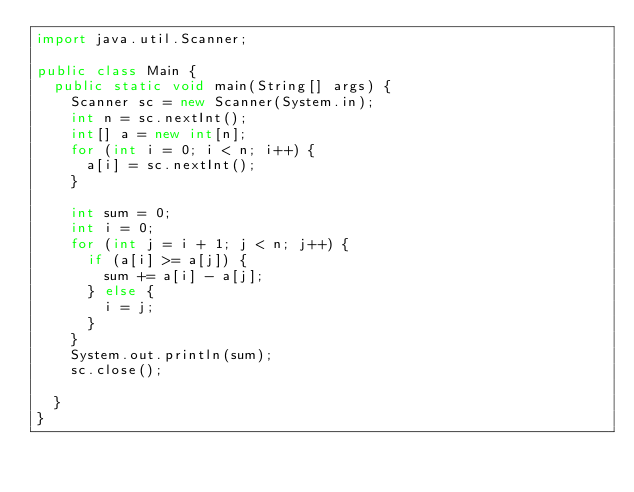<code> <loc_0><loc_0><loc_500><loc_500><_Java_>import java.util.Scanner;

public class Main {
	public static void main(String[] args) {
		Scanner sc = new Scanner(System.in);
		int n = sc.nextInt();
		int[] a = new int[n];
		for (int i = 0; i < n; i++) {
			a[i] = sc.nextInt();
		}

		int sum = 0;
		int i = 0;
		for (int j = i + 1; j < n; j++) {
			if (a[i] >= a[j]) {
				sum += a[i] - a[j];
			} else {
				i = j;
			}
		}
		System.out.println(sum);
		sc.close();
	
	}
}
</code> 